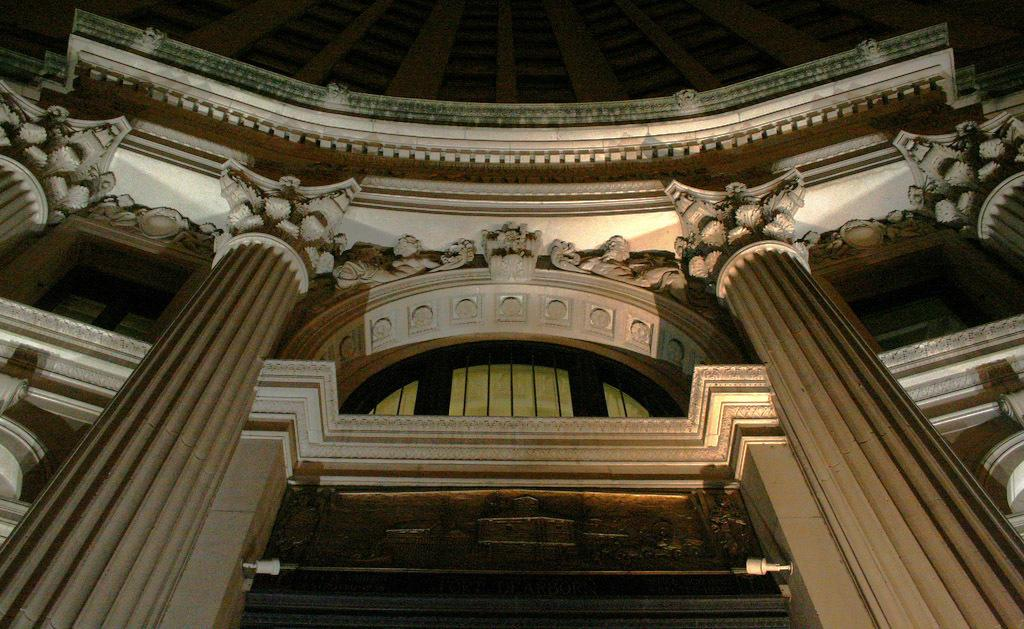What type of structure is visible in the image? There is a building in the image. What type of popcorn is being used to fix the window in the image? There is no popcorn or window present in the image, and therefore no such activity can be observed. 